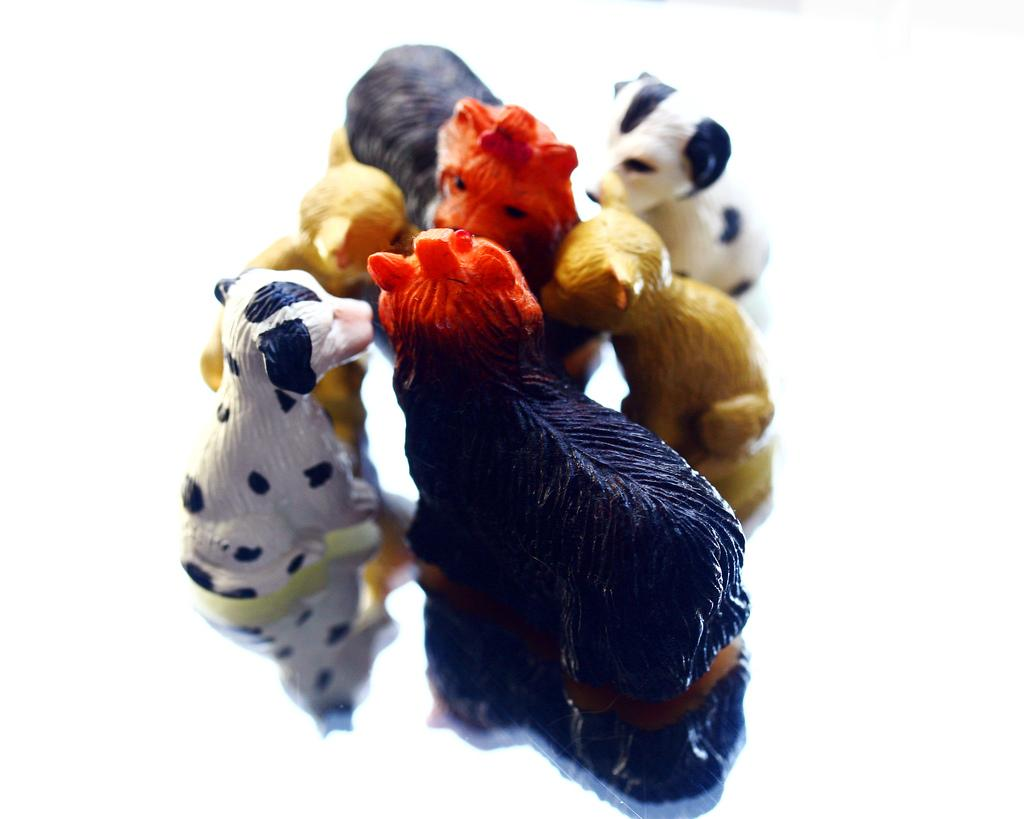What type of objects are present in the image? There are many toys in the image. Can you describe the appearance of the toys? The toys come in different colors and sizes. What type of precipitation can be seen falling on the toys in the image? There is no precipitation present in the image; it is a collection of toys with different colors and sizes. 